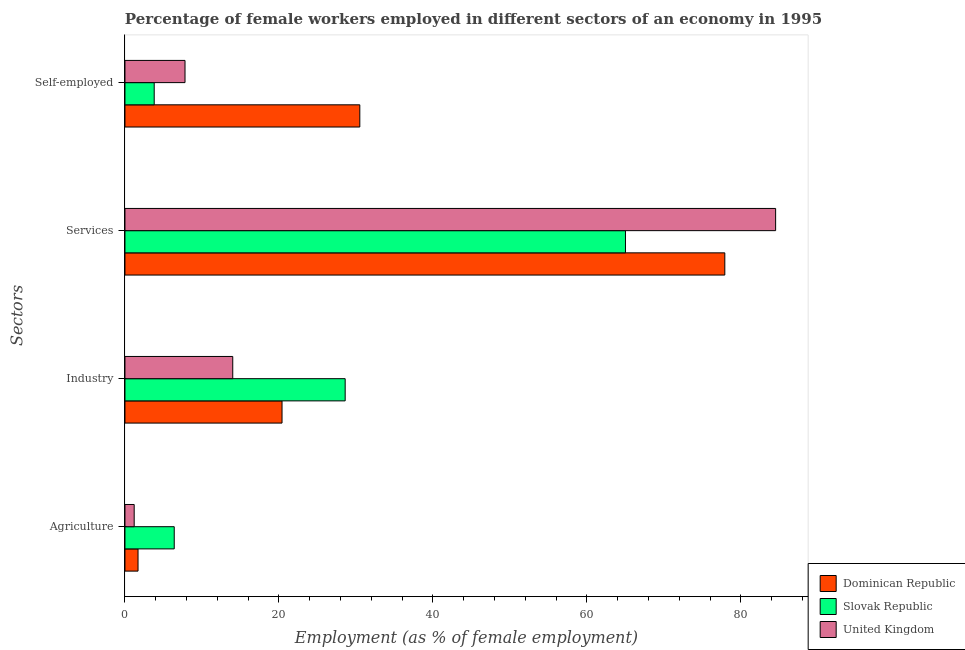Are the number of bars per tick equal to the number of legend labels?
Offer a very short reply. Yes. What is the label of the 2nd group of bars from the top?
Keep it short and to the point. Services. What is the percentage of female workers in agriculture in United Kingdom?
Make the answer very short. 1.2. Across all countries, what is the maximum percentage of female workers in agriculture?
Give a very brief answer. 6.4. In which country was the percentage of self employed female workers maximum?
Offer a terse response. Dominican Republic. In which country was the percentage of female workers in agriculture minimum?
Ensure brevity in your answer.  United Kingdom. What is the total percentage of female workers in industry in the graph?
Provide a succinct answer. 63. What is the difference between the percentage of female workers in services in Dominican Republic and that in Slovak Republic?
Provide a short and direct response. 12.9. What is the difference between the percentage of female workers in agriculture in United Kingdom and the percentage of female workers in services in Dominican Republic?
Make the answer very short. -76.7. What is the average percentage of female workers in agriculture per country?
Make the answer very short. 3.1. What is the difference between the percentage of self employed female workers and percentage of female workers in industry in Slovak Republic?
Ensure brevity in your answer.  -24.8. What is the ratio of the percentage of self employed female workers in United Kingdom to that in Slovak Republic?
Ensure brevity in your answer.  2.05. Is the difference between the percentage of female workers in agriculture in Dominican Republic and Slovak Republic greater than the difference between the percentage of self employed female workers in Dominican Republic and Slovak Republic?
Offer a very short reply. No. What is the difference between the highest and the second highest percentage of self employed female workers?
Provide a succinct answer. 22.7. What is the difference between the highest and the lowest percentage of female workers in services?
Make the answer very short. 19.5. In how many countries, is the percentage of self employed female workers greater than the average percentage of self employed female workers taken over all countries?
Your answer should be very brief. 1. What does the 1st bar from the top in Industry represents?
Your answer should be very brief. United Kingdom. What does the 2nd bar from the bottom in Services represents?
Provide a succinct answer. Slovak Republic. Is it the case that in every country, the sum of the percentage of female workers in agriculture and percentage of female workers in industry is greater than the percentage of female workers in services?
Offer a very short reply. No. How many bars are there?
Keep it short and to the point. 12. How many countries are there in the graph?
Your response must be concise. 3. What is the difference between two consecutive major ticks on the X-axis?
Provide a short and direct response. 20. Does the graph contain any zero values?
Ensure brevity in your answer.  No. How many legend labels are there?
Your answer should be compact. 3. What is the title of the graph?
Your answer should be very brief. Percentage of female workers employed in different sectors of an economy in 1995. What is the label or title of the X-axis?
Offer a terse response. Employment (as % of female employment). What is the label or title of the Y-axis?
Provide a succinct answer. Sectors. What is the Employment (as % of female employment) of Dominican Republic in Agriculture?
Provide a short and direct response. 1.7. What is the Employment (as % of female employment) of Slovak Republic in Agriculture?
Your answer should be compact. 6.4. What is the Employment (as % of female employment) in United Kingdom in Agriculture?
Ensure brevity in your answer.  1.2. What is the Employment (as % of female employment) of Dominican Republic in Industry?
Give a very brief answer. 20.4. What is the Employment (as % of female employment) of Slovak Republic in Industry?
Make the answer very short. 28.6. What is the Employment (as % of female employment) of Dominican Republic in Services?
Give a very brief answer. 77.9. What is the Employment (as % of female employment) of Slovak Republic in Services?
Ensure brevity in your answer.  65. What is the Employment (as % of female employment) in United Kingdom in Services?
Offer a terse response. 84.5. What is the Employment (as % of female employment) of Dominican Republic in Self-employed?
Keep it short and to the point. 30.5. What is the Employment (as % of female employment) of Slovak Republic in Self-employed?
Your response must be concise. 3.8. What is the Employment (as % of female employment) in United Kingdom in Self-employed?
Your response must be concise. 7.8. Across all Sectors, what is the maximum Employment (as % of female employment) of Dominican Republic?
Your answer should be compact. 77.9. Across all Sectors, what is the maximum Employment (as % of female employment) in United Kingdom?
Keep it short and to the point. 84.5. Across all Sectors, what is the minimum Employment (as % of female employment) in Dominican Republic?
Offer a very short reply. 1.7. Across all Sectors, what is the minimum Employment (as % of female employment) in Slovak Republic?
Provide a succinct answer. 3.8. Across all Sectors, what is the minimum Employment (as % of female employment) in United Kingdom?
Give a very brief answer. 1.2. What is the total Employment (as % of female employment) in Dominican Republic in the graph?
Make the answer very short. 130.5. What is the total Employment (as % of female employment) of Slovak Republic in the graph?
Keep it short and to the point. 103.8. What is the total Employment (as % of female employment) in United Kingdom in the graph?
Offer a very short reply. 107.5. What is the difference between the Employment (as % of female employment) in Dominican Republic in Agriculture and that in Industry?
Your answer should be compact. -18.7. What is the difference between the Employment (as % of female employment) in Slovak Republic in Agriculture and that in Industry?
Your answer should be compact. -22.2. What is the difference between the Employment (as % of female employment) in Dominican Republic in Agriculture and that in Services?
Your response must be concise. -76.2. What is the difference between the Employment (as % of female employment) of Slovak Republic in Agriculture and that in Services?
Offer a very short reply. -58.6. What is the difference between the Employment (as % of female employment) in United Kingdom in Agriculture and that in Services?
Make the answer very short. -83.3. What is the difference between the Employment (as % of female employment) in Dominican Republic in Agriculture and that in Self-employed?
Offer a very short reply. -28.8. What is the difference between the Employment (as % of female employment) of Dominican Republic in Industry and that in Services?
Give a very brief answer. -57.5. What is the difference between the Employment (as % of female employment) in Slovak Republic in Industry and that in Services?
Provide a succinct answer. -36.4. What is the difference between the Employment (as % of female employment) of United Kingdom in Industry and that in Services?
Offer a very short reply. -70.5. What is the difference between the Employment (as % of female employment) of Dominican Republic in Industry and that in Self-employed?
Give a very brief answer. -10.1. What is the difference between the Employment (as % of female employment) of Slovak Republic in Industry and that in Self-employed?
Offer a terse response. 24.8. What is the difference between the Employment (as % of female employment) of United Kingdom in Industry and that in Self-employed?
Provide a succinct answer. 6.2. What is the difference between the Employment (as % of female employment) in Dominican Republic in Services and that in Self-employed?
Give a very brief answer. 47.4. What is the difference between the Employment (as % of female employment) of Slovak Republic in Services and that in Self-employed?
Your response must be concise. 61.2. What is the difference between the Employment (as % of female employment) in United Kingdom in Services and that in Self-employed?
Offer a terse response. 76.7. What is the difference between the Employment (as % of female employment) in Dominican Republic in Agriculture and the Employment (as % of female employment) in Slovak Republic in Industry?
Ensure brevity in your answer.  -26.9. What is the difference between the Employment (as % of female employment) in Dominican Republic in Agriculture and the Employment (as % of female employment) in United Kingdom in Industry?
Offer a very short reply. -12.3. What is the difference between the Employment (as % of female employment) in Dominican Republic in Agriculture and the Employment (as % of female employment) in Slovak Republic in Services?
Your answer should be very brief. -63.3. What is the difference between the Employment (as % of female employment) in Dominican Republic in Agriculture and the Employment (as % of female employment) in United Kingdom in Services?
Your response must be concise. -82.8. What is the difference between the Employment (as % of female employment) in Slovak Republic in Agriculture and the Employment (as % of female employment) in United Kingdom in Services?
Provide a succinct answer. -78.1. What is the difference between the Employment (as % of female employment) of Slovak Republic in Agriculture and the Employment (as % of female employment) of United Kingdom in Self-employed?
Provide a short and direct response. -1.4. What is the difference between the Employment (as % of female employment) in Dominican Republic in Industry and the Employment (as % of female employment) in Slovak Republic in Services?
Ensure brevity in your answer.  -44.6. What is the difference between the Employment (as % of female employment) in Dominican Republic in Industry and the Employment (as % of female employment) in United Kingdom in Services?
Offer a terse response. -64.1. What is the difference between the Employment (as % of female employment) of Slovak Republic in Industry and the Employment (as % of female employment) of United Kingdom in Services?
Make the answer very short. -55.9. What is the difference between the Employment (as % of female employment) in Slovak Republic in Industry and the Employment (as % of female employment) in United Kingdom in Self-employed?
Ensure brevity in your answer.  20.8. What is the difference between the Employment (as % of female employment) of Dominican Republic in Services and the Employment (as % of female employment) of Slovak Republic in Self-employed?
Provide a succinct answer. 74.1. What is the difference between the Employment (as % of female employment) in Dominican Republic in Services and the Employment (as % of female employment) in United Kingdom in Self-employed?
Provide a succinct answer. 70.1. What is the difference between the Employment (as % of female employment) in Slovak Republic in Services and the Employment (as % of female employment) in United Kingdom in Self-employed?
Offer a terse response. 57.2. What is the average Employment (as % of female employment) of Dominican Republic per Sectors?
Your answer should be compact. 32.62. What is the average Employment (as % of female employment) of Slovak Republic per Sectors?
Offer a terse response. 25.95. What is the average Employment (as % of female employment) of United Kingdom per Sectors?
Offer a very short reply. 26.88. What is the difference between the Employment (as % of female employment) of Dominican Republic and Employment (as % of female employment) of United Kingdom in Agriculture?
Offer a very short reply. 0.5. What is the difference between the Employment (as % of female employment) of Slovak Republic and Employment (as % of female employment) of United Kingdom in Agriculture?
Keep it short and to the point. 5.2. What is the difference between the Employment (as % of female employment) of Dominican Republic and Employment (as % of female employment) of United Kingdom in Industry?
Offer a terse response. 6.4. What is the difference between the Employment (as % of female employment) of Dominican Republic and Employment (as % of female employment) of Slovak Republic in Services?
Ensure brevity in your answer.  12.9. What is the difference between the Employment (as % of female employment) of Slovak Republic and Employment (as % of female employment) of United Kingdom in Services?
Keep it short and to the point. -19.5. What is the difference between the Employment (as % of female employment) of Dominican Republic and Employment (as % of female employment) of Slovak Republic in Self-employed?
Provide a short and direct response. 26.7. What is the difference between the Employment (as % of female employment) in Dominican Republic and Employment (as % of female employment) in United Kingdom in Self-employed?
Ensure brevity in your answer.  22.7. What is the ratio of the Employment (as % of female employment) in Dominican Republic in Agriculture to that in Industry?
Offer a very short reply. 0.08. What is the ratio of the Employment (as % of female employment) of Slovak Republic in Agriculture to that in Industry?
Your response must be concise. 0.22. What is the ratio of the Employment (as % of female employment) of United Kingdom in Agriculture to that in Industry?
Your answer should be very brief. 0.09. What is the ratio of the Employment (as % of female employment) in Dominican Republic in Agriculture to that in Services?
Give a very brief answer. 0.02. What is the ratio of the Employment (as % of female employment) of Slovak Republic in Agriculture to that in Services?
Provide a short and direct response. 0.1. What is the ratio of the Employment (as % of female employment) of United Kingdom in Agriculture to that in Services?
Keep it short and to the point. 0.01. What is the ratio of the Employment (as % of female employment) of Dominican Republic in Agriculture to that in Self-employed?
Ensure brevity in your answer.  0.06. What is the ratio of the Employment (as % of female employment) in Slovak Republic in Agriculture to that in Self-employed?
Ensure brevity in your answer.  1.68. What is the ratio of the Employment (as % of female employment) in United Kingdom in Agriculture to that in Self-employed?
Ensure brevity in your answer.  0.15. What is the ratio of the Employment (as % of female employment) in Dominican Republic in Industry to that in Services?
Keep it short and to the point. 0.26. What is the ratio of the Employment (as % of female employment) of Slovak Republic in Industry to that in Services?
Your response must be concise. 0.44. What is the ratio of the Employment (as % of female employment) in United Kingdom in Industry to that in Services?
Ensure brevity in your answer.  0.17. What is the ratio of the Employment (as % of female employment) in Dominican Republic in Industry to that in Self-employed?
Your response must be concise. 0.67. What is the ratio of the Employment (as % of female employment) of Slovak Republic in Industry to that in Self-employed?
Provide a succinct answer. 7.53. What is the ratio of the Employment (as % of female employment) in United Kingdom in Industry to that in Self-employed?
Your answer should be compact. 1.79. What is the ratio of the Employment (as % of female employment) of Dominican Republic in Services to that in Self-employed?
Your answer should be compact. 2.55. What is the ratio of the Employment (as % of female employment) of Slovak Republic in Services to that in Self-employed?
Your response must be concise. 17.11. What is the ratio of the Employment (as % of female employment) of United Kingdom in Services to that in Self-employed?
Offer a very short reply. 10.83. What is the difference between the highest and the second highest Employment (as % of female employment) in Dominican Republic?
Your answer should be compact. 47.4. What is the difference between the highest and the second highest Employment (as % of female employment) of Slovak Republic?
Your answer should be very brief. 36.4. What is the difference between the highest and the second highest Employment (as % of female employment) of United Kingdom?
Give a very brief answer. 70.5. What is the difference between the highest and the lowest Employment (as % of female employment) of Dominican Republic?
Your response must be concise. 76.2. What is the difference between the highest and the lowest Employment (as % of female employment) in Slovak Republic?
Give a very brief answer. 61.2. What is the difference between the highest and the lowest Employment (as % of female employment) in United Kingdom?
Offer a very short reply. 83.3. 